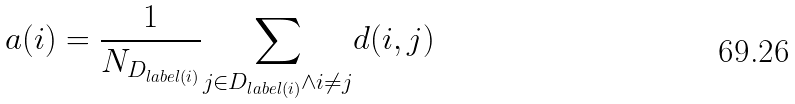Convert formula to latex. <formula><loc_0><loc_0><loc_500><loc_500>a ( i ) = \frac { 1 } { N _ { D _ { l a b e l ( i ) } } } \underset { j \in D _ { l a b e l ( i ) } \wedge i \neq j } { \sum } d ( i , j )</formula> 